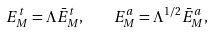Convert formula to latex. <formula><loc_0><loc_0><loc_500><loc_500>E ^ { t } _ { M } = \Lambda \bar { E } ^ { t } _ { M } , \quad E ^ { a } _ { M } = \Lambda ^ { 1 / 2 } \bar { E } ^ { a } _ { M } ,</formula> 